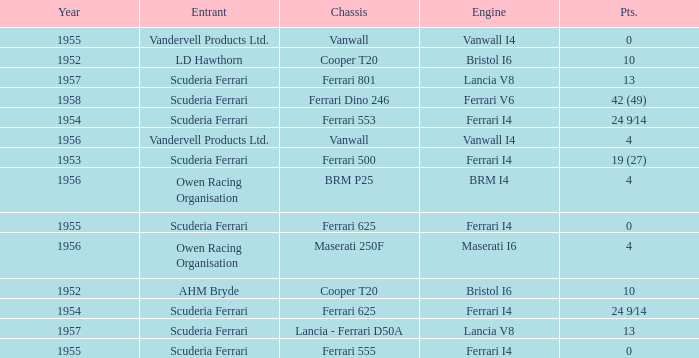How many points were scored when the Chassis is BRM p25? 4.0. 